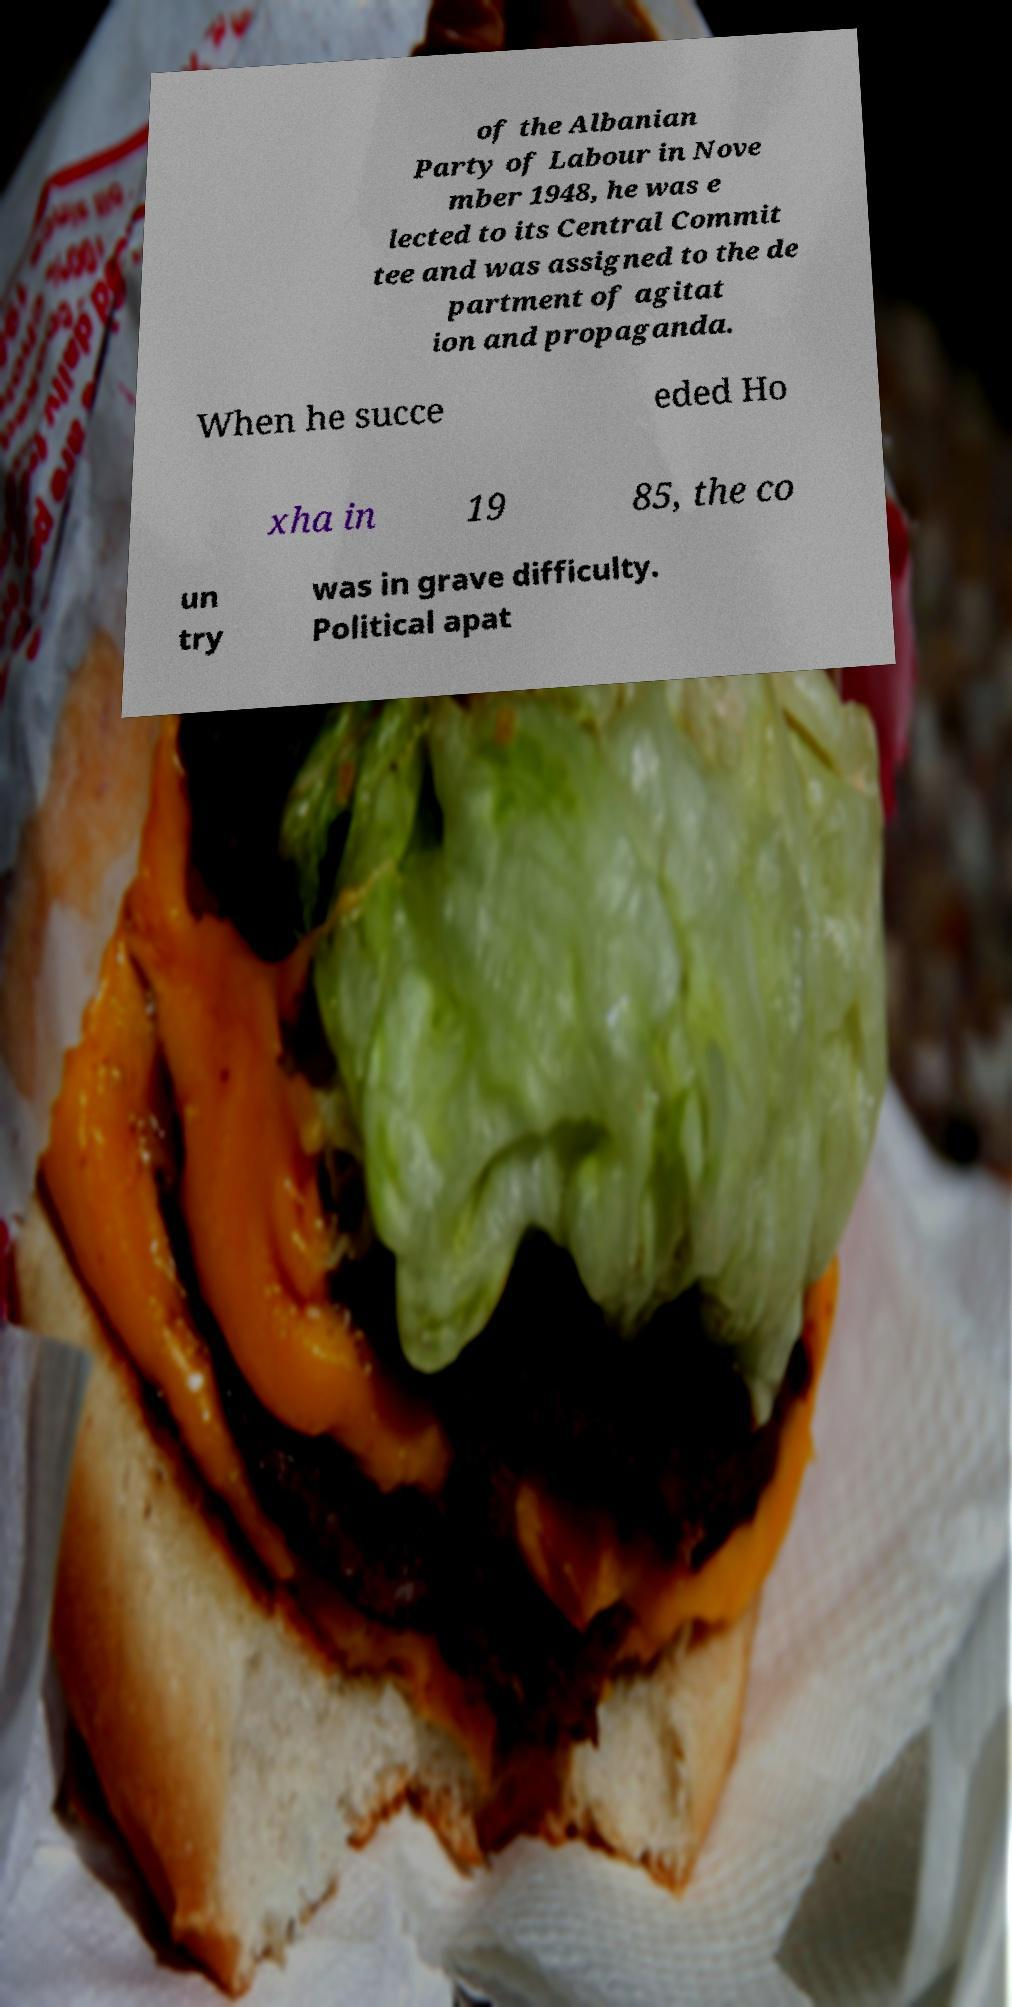Could you extract and type out the text from this image? of the Albanian Party of Labour in Nove mber 1948, he was e lected to its Central Commit tee and was assigned to the de partment of agitat ion and propaganda. When he succe eded Ho xha in 19 85, the co un try was in grave difficulty. Political apat 